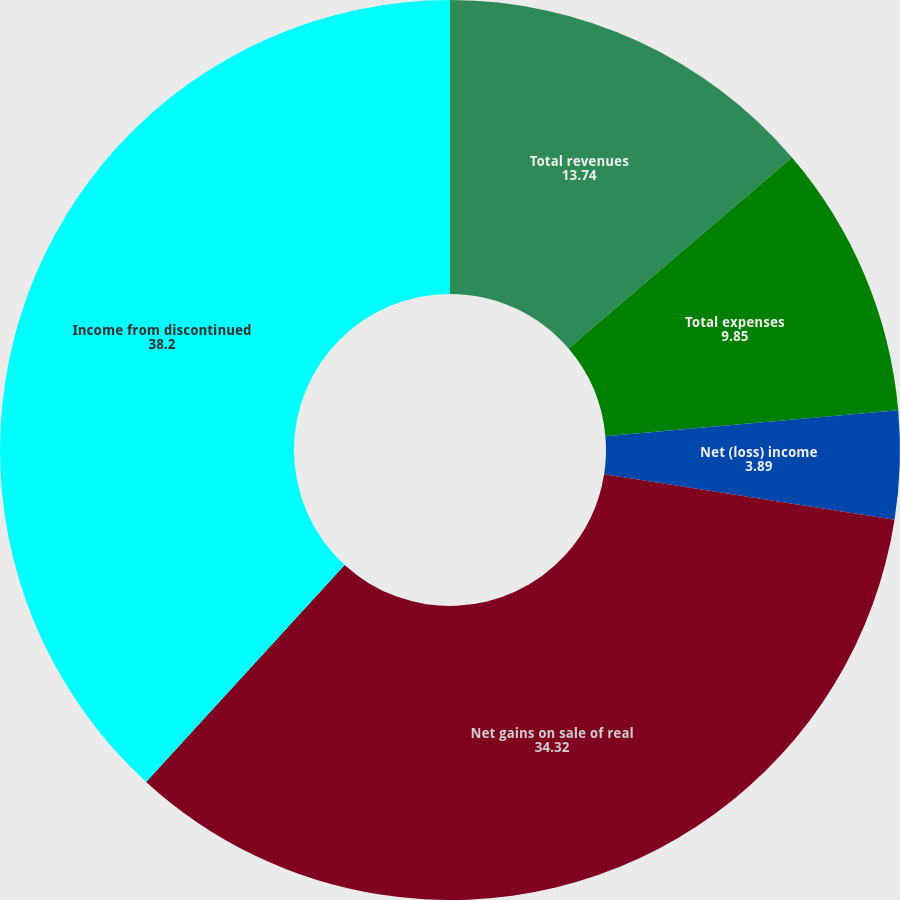Convert chart. <chart><loc_0><loc_0><loc_500><loc_500><pie_chart><fcel>Total revenues<fcel>Total expenses<fcel>Net (loss) income<fcel>Net gains on sale of real<fcel>Income from discontinued<nl><fcel>13.74%<fcel>9.85%<fcel>3.89%<fcel>34.32%<fcel>38.2%<nl></chart> 